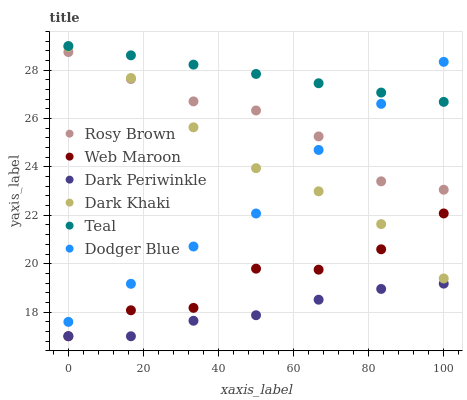Does Dark Periwinkle have the minimum area under the curve?
Answer yes or no. Yes. Does Teal have the maximum area under the curve?
Answer yes or no. Yes. Does Web Maroon have the minimum area under the curve?
Answer yes or no. No. Does Web Maroon have the maximum area under the curve?
Answer yes or no. No. Is Teal the smoothest?
Answer yes or no. Yes. Is Web Maroon the roughest?
Answer yes or no. Yes. Is Dark Khaki the smoothest?
Answer yes or no. No. Is Dark Khaki the roughest?
Answer yes or no. No. Does Web Maroon have the lowest value?
Answer yes or no. Yes. Does Dark Khaki have the lowest value?
Answer yes or no. No. Does Teal have the highest value?
Answer yes or no. Yes. Does Web Maroon have the highest value?
Answer yes or no. No. Is Web Maroon less than Dodger Blue?
Answer yes or no. Yes. Is Teal greater than Web Maroon?
Answer yes or no. Yes. Does Dodger Blue intersect Dark Khaki?
Answer yes or no. Yes. Is Dodger Blue less than Dark Khaki?
Answer yes or no. No. Is Dodger Blue greater than Dark Khaki?
Answer yes or no. No. Does Web Maroon intersect Dodger Blue?
Answer yes or no. No. 